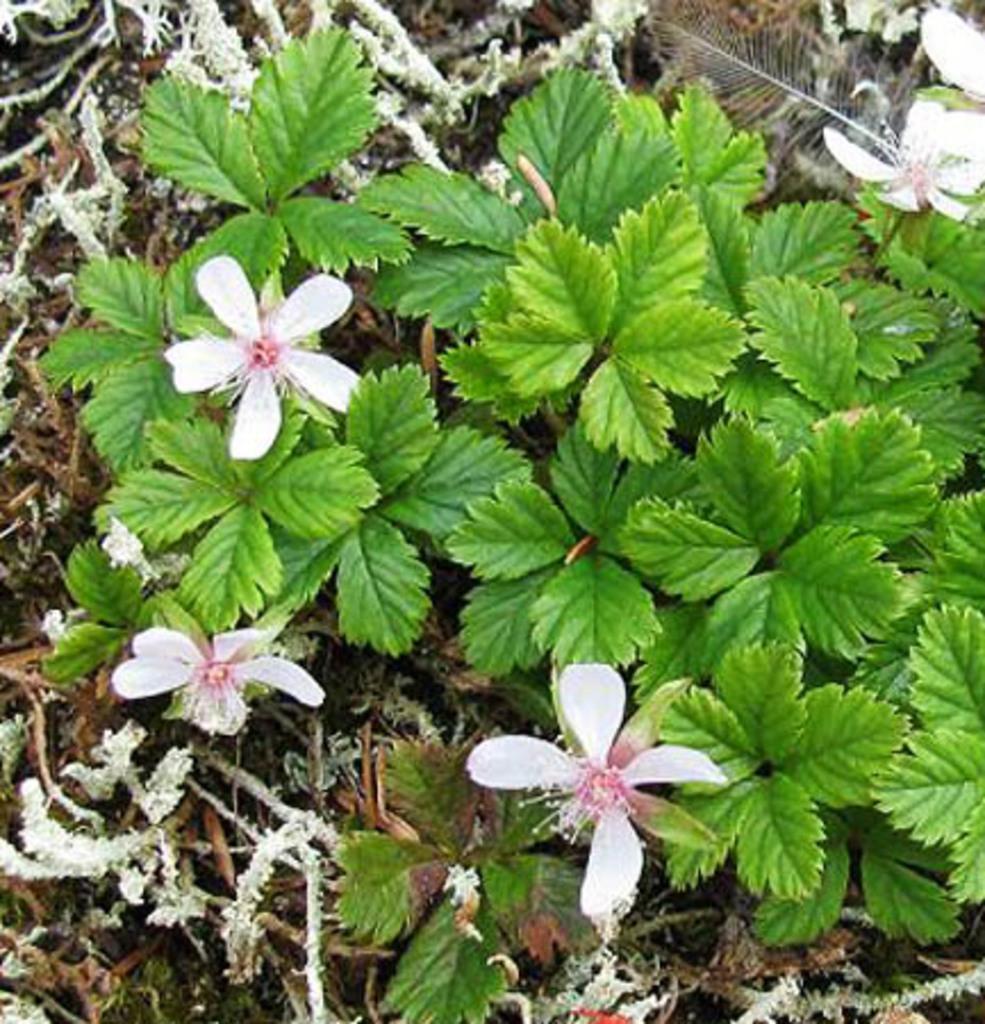Please provide a concise description of this image. Here in this picture we can see plants present on the ground over there and we can also see flowers on it here and there. 